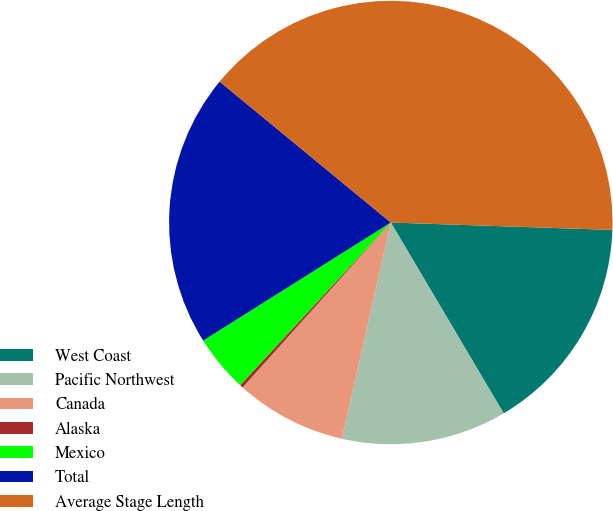Convert chart. <chart><loc_0><loc_0><loc_500><loc_500><pie_chart><fcel>West Coast<fcel>Pacific Northwest<fcel>Canada<fcel>Alaska<fcel>Mexico<fcel>Total<fcel>Average Stage Length<nl><fcel>15.97%<fcel>12.04%<fcel>8.11%<fcel>0.24%<fcel>4.17%<fcel>19.9%<fcel>39.57%<nl></chart> 